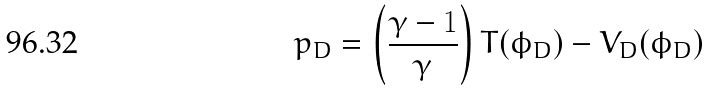Convert formula to latex. <formula><loc_0><loc_0><loc_500><loc_500>p _ { D } = \left ( \frac { \gamma - 1 } { \gamma } \right ) T ( \phi _ { D } ) - V _ { D } ( \phi _ { D } )</formula> 